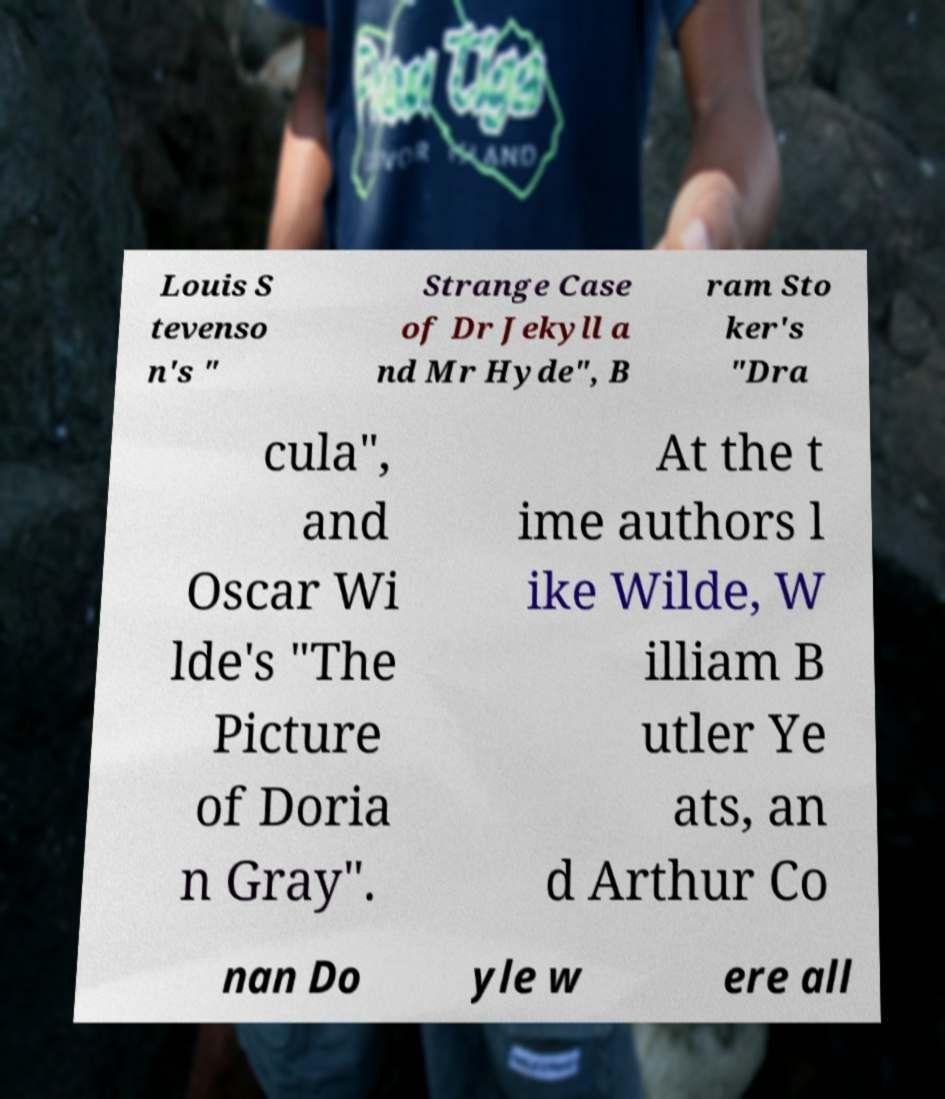What messages or text are displayed in this image? I need them in a readable, typed format. Louis S tevenso n's " Strange Case of Dr Jekyll a nd Mr Hyde", B ram Sto ker's "Dra cula", and Oscar Wi lde's "The Picture of Doria n Gray". At the t ime authors l ike Wilde, W illiam B utler Ye ats, an d Arthur Co nan Do yle w ere all 